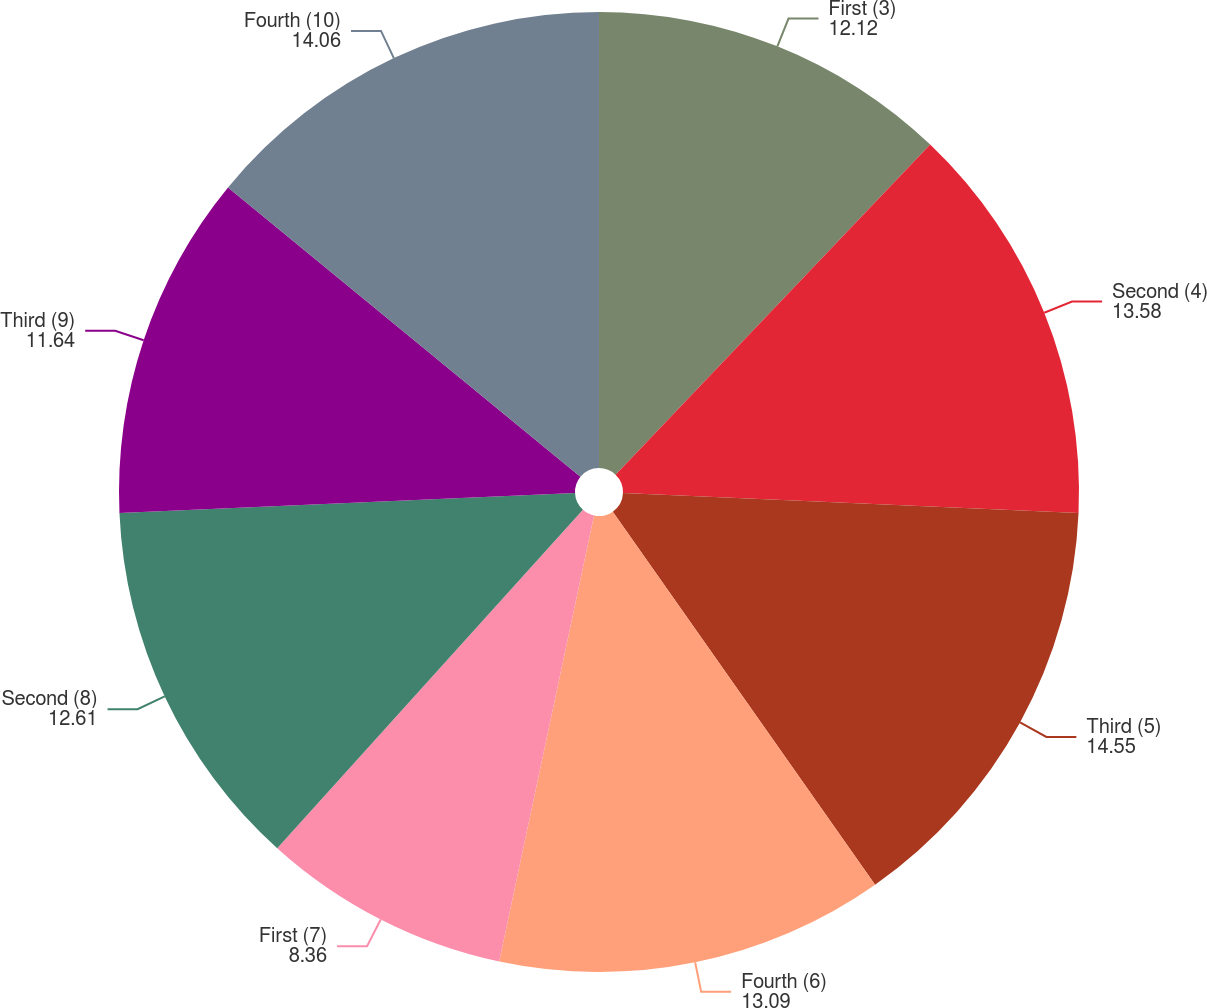Convert chart. <chart><loc_0><loc_0><loc_500><loc_500><pie_chart><fcel>First (3)<fcel>Second (4)<fcel>Third (5)<fcel>Fourth (6)<fcel>First (7)<fcel>Second (8)<fcel>Third (9)<fcel>Fourth (10)<nl><fcel>12.12%<fcel>13.58%<fcel>14.55%<fcel>13.09%<fcel>8.36%<fcel>12.61%<fcel>11.64%<fcel>14.06%<nl></chart> 